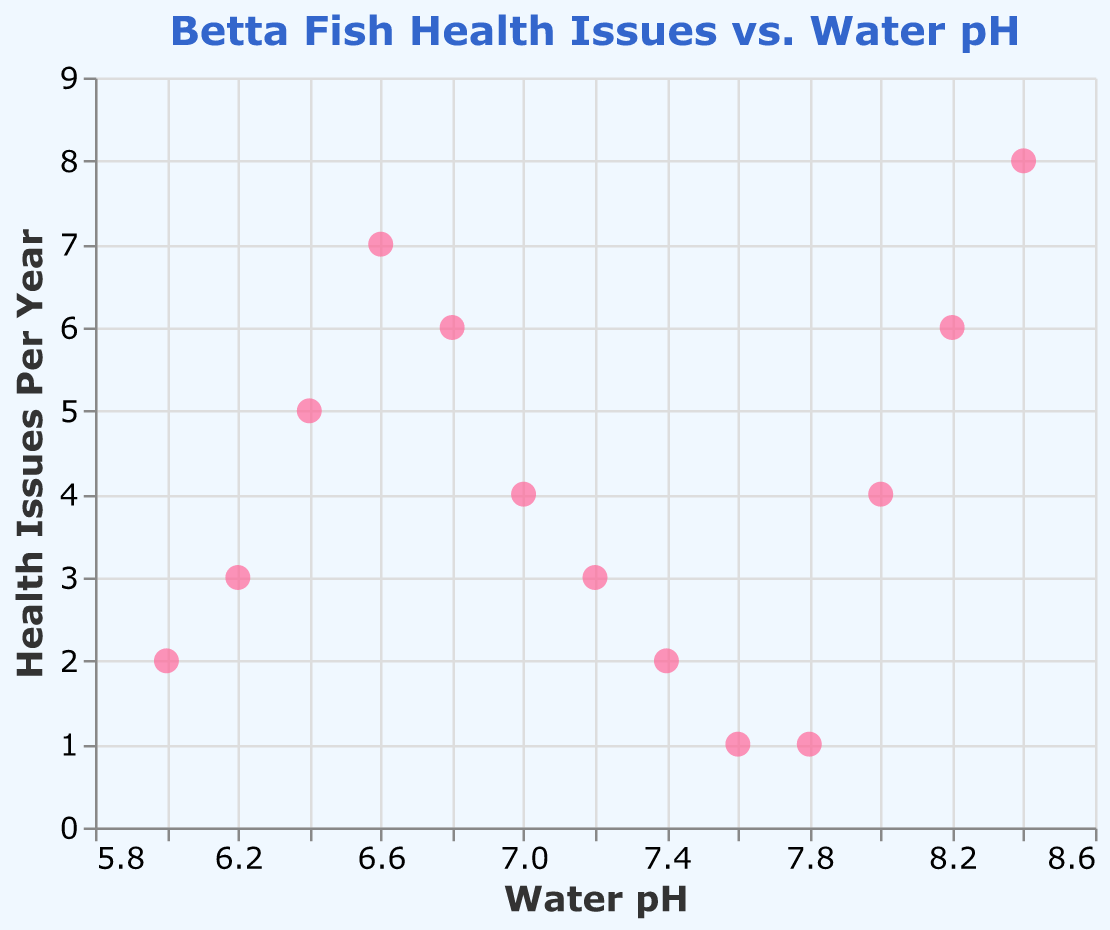What is the title of the plot? The title of the plot is displayed at the top of the figure. In this case, it reads "Betta Fish Health Issues vs. Water pH".
Answer: Betta Fish Health Issues vs. Water pH How many data points are there in the plot? The number of data points can be counted from the marks in the scatter plot. By counting all the points, we see there are 13 data points in the figure.
Answer: 13 What is the highest number of health issues per year observed, and at what pH level does it occur? To find the highest number of health issues per year, we look at the y-axis and find the maximum value, which is 8. This value occurs at a water pH of 8.4 as indicated by the corresponding point.
Answer: 8, occurring at pH 8.4 At which pH levels do the fish experience just 1 health issue per year? We look at the y-axis for the value 1 and find which pH levels correspond to this value. There are two points: at pH levels 7.6 and 7.8.
Answer: pH 7.6 and 7.8 What is the trend in health issues as pH ranges from 6.0 to 7.0? Observing the scatter plot from pH 6.0 to 7.0, there is an increasing trend in health issues, peaking at pH 6.6, and then slightly decreasing at pH 7.0. This shows an overall increase at first, then a slight decrease.
Answer: Increase, then slight decrease What is the average number of health issues per year for pH levels of 6.0, 6.2, and 6.4? To find the average, sum the health issues for pH 6.0 (2), 6.2 (3), and 6.4 (5) and divide by the number of points (3). Calculation: (2+3+5)/3 = 10/3 = 3.33.
Answer: 3.33 Does any pH level have the same number of health issues as pH 7.0? We identify the number of health issues at pH 7.0, which is 4, and then check if any other pH levels also have 4 health issues. The pH level 8.0 also has 4 health issues per year.
Answer: pH 8.0 Between which pH levels do fish experience a consistent decrease in health issues? Examining the scatter plot, from pH 6.6 (7 issues) to pH 7.8 (1 issue), there is a consistent decrease in health issues.
Answer: pH 6.6 to pH 7.8 How does the number of health issues at pH 6.8 compare to that at pH 7.4? The number of health issues at pH 6.8 is 6. At pH 7.4, it is 2. By comparison, there are more health issues at pH 6.8.
Answer: More at pH 6.8 What is the sum of health issues for pH levels with the lowest and highest observed issues? The lowest observed issues are at pH 7.6 and 7.8 with 1 each, and the highest is at pH 8.4 with 8 issues. The sum is 1 + 1 + 8 = 10.
Answer: 10 